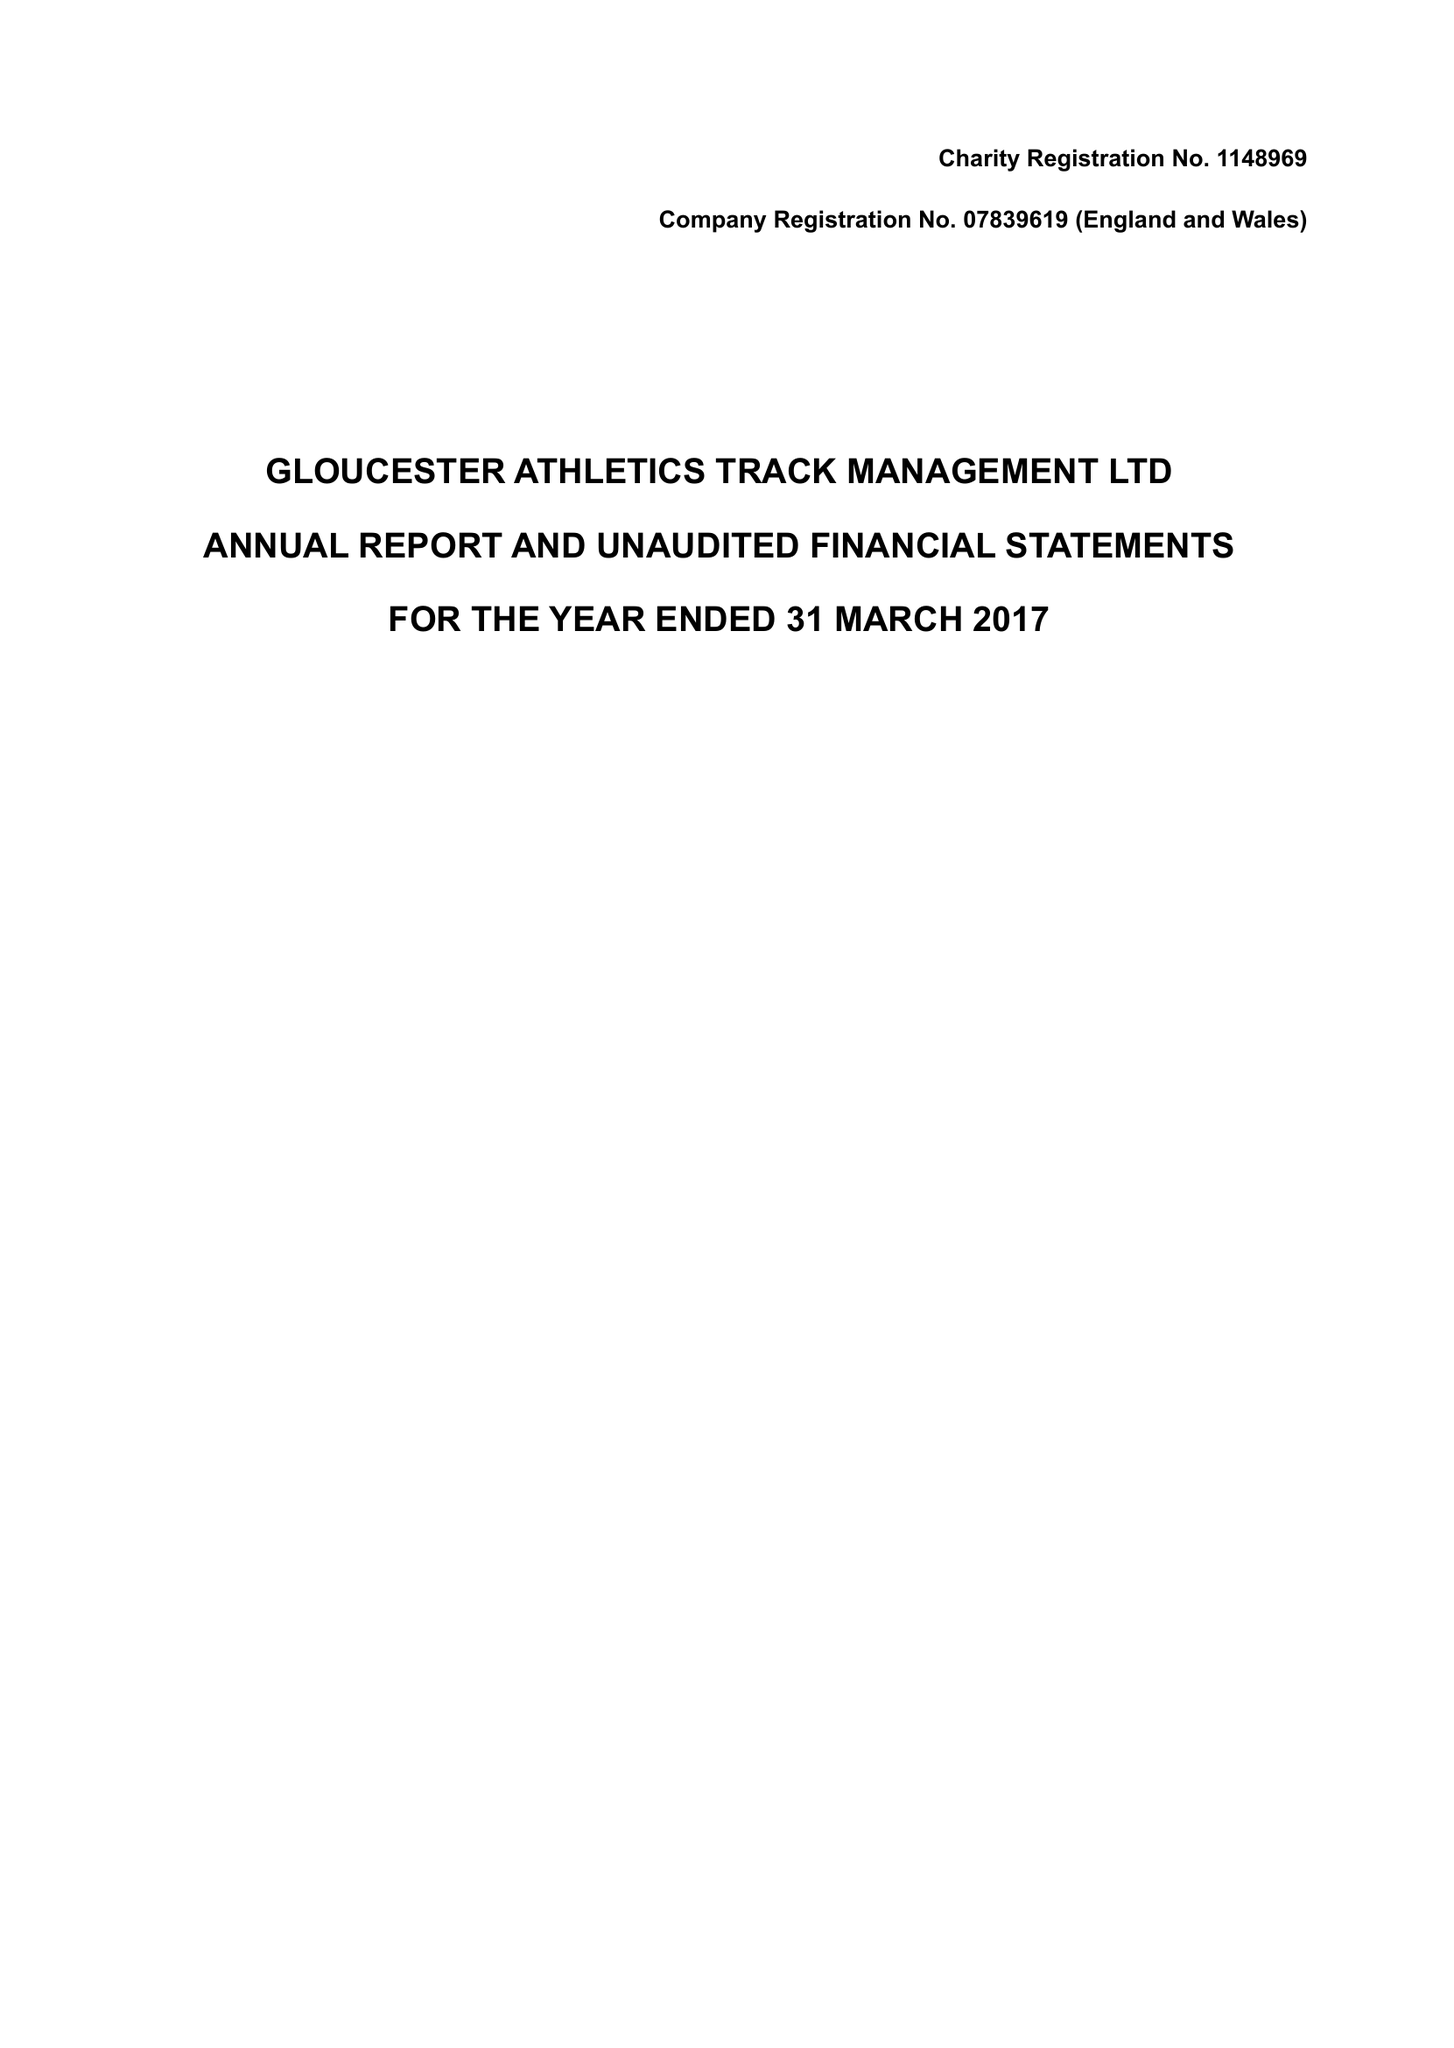What is the value for the report_date?
Answer the question using a single word or phrase. 2017-03-31 